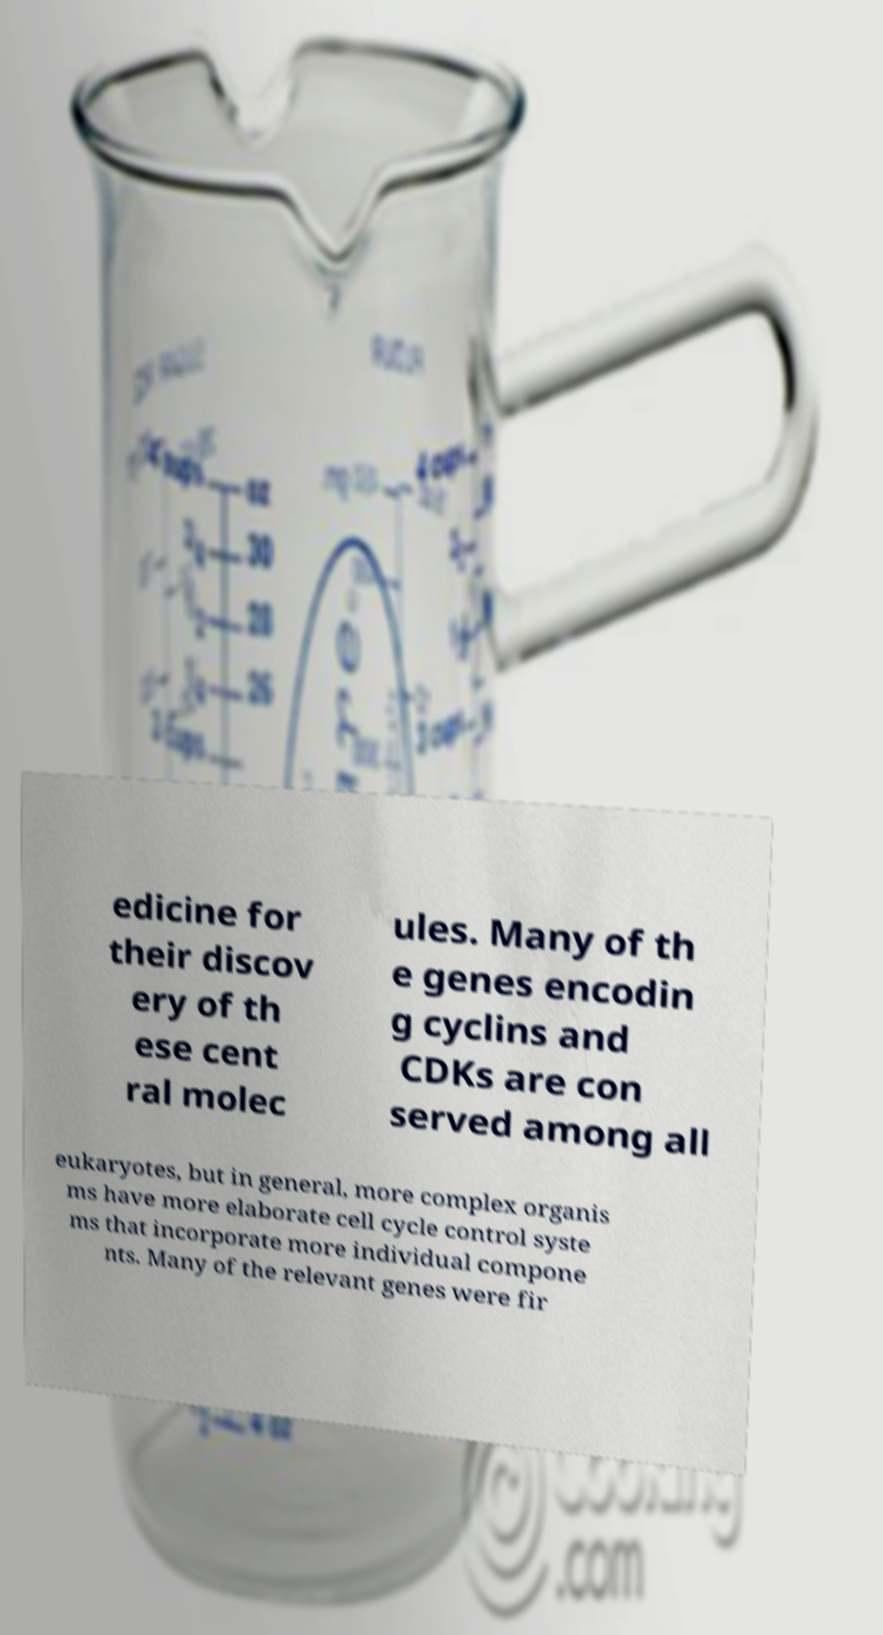There's text embedded in this image that I need extracted. Can you transcribe it verbatim? edicine for their discov ery of th ese cent ral molec ules. Many of th e genes encodin g cyclins and CDKs are con served among all eukaryotes, but in general, more complex organis ms have more elaborate cell cycle control syste ms that incorporate more individual compone nts. Many of the relevant genes were fir 